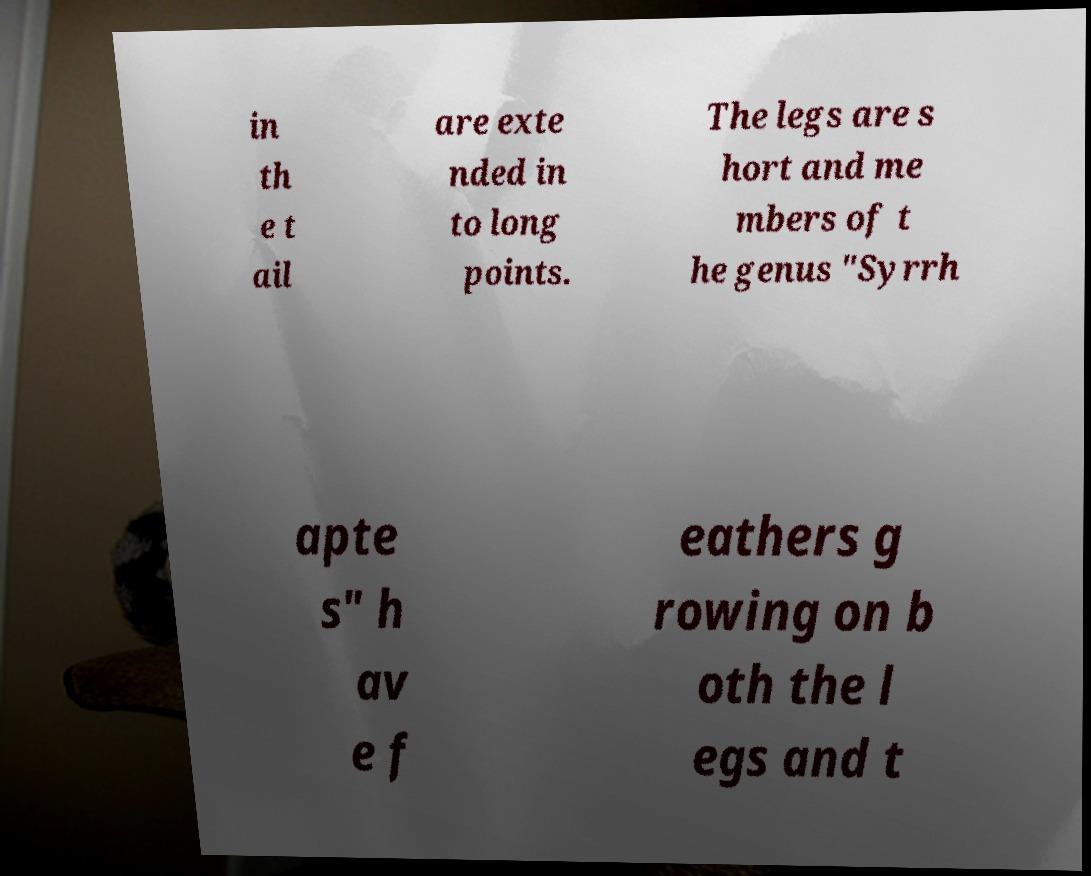I need the written content from this picture converted into text. Can you do that? in th e t ail are exte nded in to long points. The legs are s hort and me mbers of t he genus "Syrrh apte s" h av e f eathers g rowing on b oth the l egs and t 